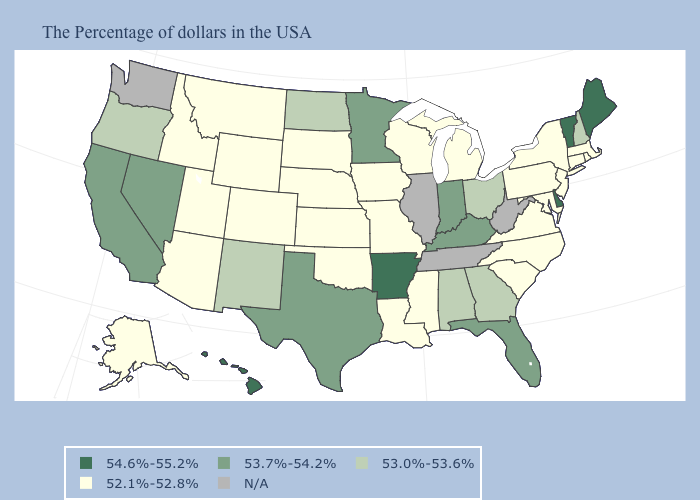What is the value of Wyoming?
Quick response, please. 52.1%-52.8%. Among the states that border Alabama , which have the highest value?
Quick response, please. Florida. What is the value of Utah?
Give a very brief answer. 52.1%-52.8%. Which states have the highest value in the USA?
Keep it brief. Maine, Vermont, Delaware, Arkansas, Hawaii. Does Maine have the highest value in the USA?
Quick response, please. Yes. Does Nevada have the highest value in the USA?
Answer briefly. No. What is the highest value in the USA?
Answer briefly. 54.6%-55.2%. Name the states that have a value in the range 53.0%-53.6%?
Concise answer only. New Hampshire, Ohio, Georgia, Alabama, North Dakota, New Mexico, Oregon. Which states hav the highest value in the South?
Be succinct. Delaware, Arkansas. Name the states that have a value in the range N/A?
Be succinct. West Virginia, Tennessee, Illinois, Washington. Among the states that border Montana , which have the highest value?
Keep it brief. North Dakota. Which states hav the highest value in the Northeast?
Quick response, please. Maine, Vermont. How many symbols are there in the legend?
Keep it brief. 5. Does Alabama have the lowest value in the South?
Give a very brief answer. No. 